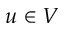Convert formula to latex. <formula><loc_0><loc_0><loc_500><loc_500>u \in V</formula> 